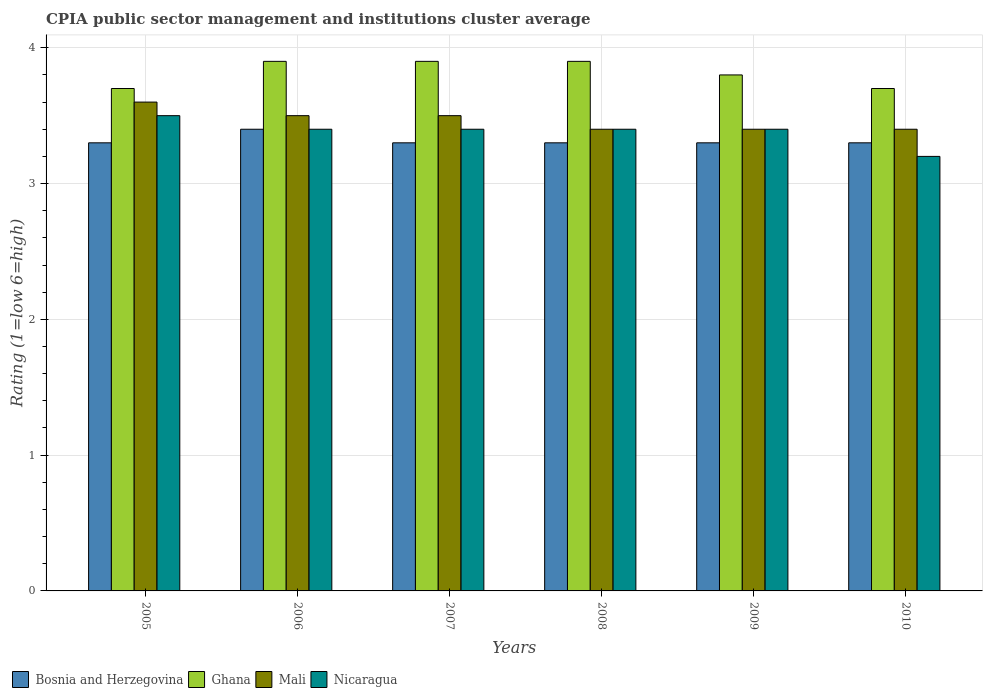Are the number of bars on each tick of the X-axis equal?
Your response must be concise. Yes. How many bars are there on the 2nd tick from the right?
Your answer should be very brief. 4. In how many cases, is the number of bars for a given year not equal to the number of legend labels?
Keep it short and to the point. 0. Across all years, what is the maximum CPIA rating in Ghana?
Give a very brief answer. 3.9. What is the total CPIA rating in Mali in the graph?
Your answer should be very brief. 20.8. What is the difference between the CPIA rating in Mali in 2005 and the CPIA rating in Bosnia and Herzegovina in 2006?
Provide a succinct answer. 0.2. What is the average CPIA rating in Mali per year?
Ensure brevity in your answer.  3.47. In the year 2008, what is the difference between the CPIA rating in Mali and CPIA rating in Nicaragua?
Your response must be concise. 0. In how many years, is the CPIA rating in Ghana greater than 2.4?
Your answer should be compact. 6. What is the ratio of the CPIA rating in Ghana in 2005 to that in 2008?
Provide a succinct answer. 0.95. Is the CPIA rating in Bosnia and Herzegovina in 2005 less than that in 2007?
Ensure brevity in your answer.  No. Is the difference between the CPIA rating in Mali in 2005 and 2006 greater than the difference between the CPIA rating in Nicaragua in 2005 and 2006?
Ensure brevity in your answer.  No. What is the difference between the highest and the second highest CPIA rating in Ghana?
Your answer should be compact. 0. What is the difference between the highest and the lowest CPIA rating in Bosnia and Herzegovina?
Keep it short and to the point. 0.1. In how many years, is the CPIA rating in Ghana greater than the average CPIA rating in Ghana taken over all years?
Provide a short and direct response. 3. Is the sum of the CPIA rating in Nicaragua in 2005 and 2010 greater than the maximum CPIA rating in Mali across all years?
Your answer should be very brief. Yes. What does the 1st bar from the left in 2010 represents?
Ensure brevity in your answer.  Bosnia and Herzegovina. What does the 4th bar from the right in 2009 represents?
Give a very brief answer. Bosnia and Herzegovina. Is it the case that in every year, the sum of the CPIA rating in Bosnia and Herzegovina and CPIA rating in Ghana is greater than the CPIA rating in Mali?
Ensure brevity in your answer.  Yes. How many bars are there?
Your answer should be very brief. 24. Are all the bars in the graph horizontal?
Make the answer very short. No. Are the values on the major ticks of Y-axis written in scientific E-notation?
Provide a short and direct response. No. Where does the legend appear in the graph?
Ensure brevity in your answer.  Bottom left. How many legend labels are there?
Provide a short and direct response. 4. How are the legend labels stacked?
Make the answer very short. Horizontal. What is the title of the graph?
Make the answer very short. CPIA public sector management and institutions cluster average. What is the label or title of the Y-axis?
Offer a very short reply. Rating (1=low 6=high). What is the Rating (1=low 6=high) of Ghana in 2005?
Keep it short and to the point. 3.7. What is the Rating (1=low 6=high) in Mali in 2005?
Offer a terse response. 3.6. What is the Rating (1=low 6=high) in Bosnia and Herzegovina in 2006?
Offer a very short reply. 3.4. What is the Rating (1=low 6=high) in Ghana in 2006?
Offer a terse response. 3.9. What is the Rating (1=low 6=high) of Nicaragua in 2006?
Make the answer very short. 3.4. What is the Rating (1=low 6=high) of Ghana in 2007?
Your answer should be compact. 3.9. What is the Rating (1=low 6=high) of Nicaragua in 2007?
Provide a short and direct response. 3.4. What is the Rating (1=low 6=high) in Bosnia and Herzegovina in 2008?
Provide a short and direct response. 3.3. What is the Rating (1=low 6=high) of Mali in 2008?
Your response must be concise. 3.4. What is the Rating (1=low 6=high) of Nicaragua in 2008?
Your response must be concise. 3.4. What is the Rating (1=low 6=high) of Ghana in 2009?
Your answer should be compact. 3.8. What is the Rating (1=low 6=high) in Nicaragua in 2009?
Provide a short and direct response. 3.4. What is the Rating (1=low 6=high) of Ghana in 2010?
Ensure brevity in your answer.  3.7. What is the Rating (1=low 6=high) of Nicaragua in 2010?
Offer a very short reply. 3.2. Across all years, what is the maximum Rating (1=low 6=high) of Bosnia and Herzegovina?
Provide a short and direct response. 3.4. Across all years, what is the maximum Rating (1=low 6=high) of Ghana?
Your response must be concise. 3.9. Across all years, what is the minimum Rating (1=low 6=high) in Ghana?
Your answer should be very brief. 3.7. Across all years, what is the minimum Rating (1=low 6=high) of Mali?
Provide a short and direct response. 3.4. What is the total Rating (1=low 6=high) of Bosnia and Herzegovina in the graph?
Give a very brief answer. 19.9. What is the total Rating (1=low 6=high) of Ghana in the graph?
Your answer should be compact. 22.9. What is the total Rating (1=low 6=high) of Mali in the graph?
Provide a short and direct response. 20.8. What is the total Rating (1=low 6=high) of Nicaragua in the graph?
Make the answer very short. 20.3. What is the difference between the Rating (1=low 6=high) of Bosnia and Herzegovina in 2005 and that in 2006?
Give a very brief answer. -0.1. What is the difference between the Rating (1=low 6=high) of Ghana in 2005 and that in 2006?
Make the answer very short. -0.2. What is the difference between the Rating (1=low 6=high) in Mali in 2005 and that in 2006?
Provide a short and direct response. 0.1. What is the difference between the Rating (1=low 6=high) in Nicaragua in 2005 and that in 2006?
Your answer should be compact. 0.1. What is the difference between the Rating (1=low 6=high) of Ghana in 2005 and that in 2007?
Give a very brief answer. -0.2. What is the difference between the Rating (1=low 6=high) in Bosnia and Herzegovina in 2005 and that in 2009?
Make the answer very short. 0. What is the difference between the Rating (1=low 6=high) of Ghana in 2005 and that in 2009?
Your answer should be very brief. -0.1. What is the difference between the Rating (1=low 6=high) of Bosnia and Herzegovina in 2005 and that in 2010?
Make the answer very short. 0. What is the difference between the Rating (1=low 6=high) of Bosnia and Herzegovina in 2006 and that in 2007?
Make the answer very short. 0.1. What is the difference between the Rating (1=low 6=high) of Ghana in 2006 and that in 2007?
Provide a short and direct response. 0. What is the difference between the Rating (1=low 6=high) in Mali in 2006 and that in 2007?
Your response must be concise. 0. What is the difference between the Rating (1=low 6=high) of Ghana in 2006 and that in 2008?
Make the answer very short. 0. What is the difference between the Rating (1=low 6=high) in Mali in 2006 and that in 2008?
Your answer should be very brief. 0.1. What is the difference between the Rating (1=low 6=high) in Nicaragua in 2006 and that in 2008?
Your response must be concise. 0. What is the difference between the Rating (1=low 6=high) in Ghana in 2006 and that in 2009?
Provide a short and direct response. 0.1. What is the difference between the Rating (1=low 6=high) in Bosnia and Herzegovina in 2007 and that in 2008?
Offer a terse response. 0. What is the difference between the Rating (1=low 6=high) of Mali in 2007 and that in 2008?
Offer a terse response. 0.1. What is the difference between the Rating (1=low 6=high) of Bosnia and Herzegovina in 2007 and that in 2009?
Provide a succinct answer. 0. What is the difference between the Rating (1=low 6=high) of Nicaragua in 2007 and that in 2009?
Offer a very short reply. 0. What is the difference between the Rating (1=low 6=high) in Bosnia and Herzegovina in 2007 and that in 2010?
Your answer should be compact. 0. What is the difference between the Rating (1=low 6=high) of Bosnia and Herzegovina in 2008 and that in 2009?
Your response must be concise. 0. What is the difference between the Rating (1=low 6=high) of Ghana in 2008 and that in 2009?
Keep it short and to the point. 0.1. What is the difference between the Rating (1=low 6=high) in Nicaragua in 2008 and that in 2009?
Keep it short and to the point. 0. What is the difference between the Rating (1=low 6=high) in Bosnia and Herzegovina in 2008 and that in 2010?
Give a very brief answer. 0. What is the difference between the Rating (1=low 6=high) of Ghana in 2008 and that in 2010?
Provide a succinct answer. 0.2. What is the difference between the Rating (1=low 6=high) of Mali in 2008 and that in 2010?
Ensure brevity in your answer.  0. What is the difference between the Rating (1=low 6=high) in Nicaragua in 2008 and that in 2010?
Provide a succinct answer. 0.2. What is the difference between the Rating (1=low 6=high) of Bosnia and Herzegovina in 2009 and that in 2010?
Make the answer very short. 0. What is the difference between the Rating (1=low 6=high) of Mali in 2009 and that in 2010?
Your response must be concise. 0. What is the difference between the Rating (1=low 6=high) in Nicaragua in 2009 and that in 2010?
Provide a succinct answer. 0.2. What is the difference between the Rating (1=low 6=high) of Bosnia and Herzegovina in 2005 and the Rating (1=low 6=high) of Ghana in 2006?
Offer a terse response. -0.6. What is the difference between the Rating (1=low 6=high) of Bosnia and Herzegovina in 2005 and the Rating (1=low 6=high) of Nicaragua in 2006?
Your answer should be compact. -0.1. What is the difference between the Rating (1=low 6=high) of Ghana in 2005 and the Rating (1=low 6=high) of Mali in 2006?
Provide a short and direct response. 0.2. What is the difference between the Rating (1=low 6=high) of Ghana in 2005 and the Rating (1=low 6=high) of Nicaragua in 2006?
Ensure brevity in your answer.  0.3. What is the difference between the Rating (1=low 6=high) of Bosnia and Herzegovina in 2005 and the Rating (1=low 6=high) of Ghana in 2007?
Make the answer very short. -0.6. What is the difference between the Rating (1=low 6=high) of Bosnia and Herzegovina in 2005 and the Rating (1=low 6=high) of Mali in 2007?
Provide a succinct answer. -0.2. What is the difference between the Rating (1=low 6=high) of Ghana in 2005 and the Rating (1=low 6=high) of Mali in 2007?
Your answer should be compact. 0.2. What is the difference between the Rating (1=low 6=high) of Mali in 2005 and the Rating (1=low 6=high) of Nicaragua in 2007?
Offer a very short reply. 0.2. What is the difference between the Rating (1=low 6=high) of Bosnia and Herzegovina in 2005 and the Rating (1=low 6=high) of Ghana in 2008?
Your response must be concise. -0.6. What is the difference between the Rating (1=low 6=high) in Bosnia and Herzegovina in 2005 and the Rating (1=low 6=high) in Nicaragua in 2008?
Offer a very short reply. -0.1. What is the difference between the Rating (1=low 6=high) of Mali in 2005 and the Rating (1=low 6=high) of Nicaragua in 2008?
Keep it short and to the point. 0.2. What is the difference between the Rating (1=low 6=high) in Bosnia and Herzegovina in 2005 and the Rating (1=low 6=high) in Ghana in 2009?
Ensure brevity in your answer.  -0.5. What is the difference between the Rating (1=low 6=high) of Ghana in 2005 and the Rating (1=low 6=high) of Nicaragua in 2009?
Offer a terse response. 0.3. What is the difference between the Rating (1=low 6=high) of Mali in 2005 and the Rating (1=low 6=high) of Nicaragua in 2009?
Provide a short and direct response. 0.2. What is the difference between the Rating (1=low 6=high) of Bosnia and Herzegovina in 2005 and the Rating (1=low 6=high) of Ghana in 2010?
Provide a succinct answer. -0.4. What is the difference between the Rating (1=low 6=high) in Ghana in 2005 and the Rating (1=low 6=high) in Mali in 2010?
Your answer should be very brief. 0.3. What is the difference between the Rating (1=low 6=high) of Bosnia and Herzegovina in 2006 and the Rating (1=low 6=high) of Nicaragua in 2007?
Offer a terse response. 0. What is the difference between the Rating (1=low 6=high) in Bosnia and Herzegovina in 2006 and the Rating (1=low 6=high) in Ghana in 2008?
Ensure brevity in your answer.  -0.5. What is the difference between the Rating (1=low 6=high) in Bosnia and Herzegovina in 2006 and the Rating (1=low 6=high) in Nicaragua in 2008?
Provide a succinct answer. 0. What is the difference between the Rating (1=low 6=high) in Ghana in 2006 and the Rating (1=low 6=high) in Mali in 2008?
Keep it short and to the point. 0.5. What is the difference between the Rating (1=low 6=high) in Ghana in 2006 and the Rating (1=low 6=high) in Nicaragua in 2008?
Provide a short and direct response. 0.5. What is the difference between the Rating (1=low 6=high) of Mali in 2006 and the Rating (1=low 6=high) of Nicaragua in 2008?
Your answer should be compact. 0.1. What is the difference between the Rating (1=low 6=high) in Bosnia and Herzegovina in 2006 and the Rating (1=low 6=high) in Ghana in 2009?
Keep it short and to the point. -0.4. What is the difference between the Rating (1=low 6=high) in Ghana in 2006 and the Rating (1=low 6=high) in Nicaragua in 2009?
Offer a terse response. 0.5. What is the difference between the Rating (1=low 6=high) of Mali in 2006 and the Rating (1=low 6=high) of Nicaragua in 2009?
Provide a succinct answer. 0.1. What is the difference between the Rating (1=low 6=high) of Bosnia and Herzegovina in 2006 and the Rating (1=low 6=high) of Ghana in 2010?
Offer a very short reply. -0.3. What is the difference between the Rating (1=low 6=high) in Ghana in 2006 and the Rating (1=low 6=high) in Nicaragua in 2010?
Make the answer very short. 0.7. What is the difference between the Rating (1=low 6=high) in Bosnia and Herzegovina in 2007 and the Rating (1=low 6=high) in Ghana in 2008?
Provide a succinct answer. -0.6. What is the difference between the Rating (1=low 6=high) in Bosnia and Herzegovina in 2007 and the Rating (1=low 6=high) in Mali in 2008?
Ensure brevity in your answer.  -0.1. What is the difference between the Rating (1=low 6=high) of Bosnia and Herzegovina in 2007 and the Rating (1=low 6=high) of Nicaragua in 2008?
Provide a succinct answer. -0.1. What is the difference between the Rating (1=low 6=high) in Bosnia and Herzegovina in 2007 and the Rating (1=low 6=high) in Mali in 2009?
Make the answer very short. -0.1. What is the difference between the Rating (1=low 6=high) in Bosnia and Herzegovina in 2007 and the Rating (1=low 6=high) in Nicaragua in 2009?
Provide a short and direct response. -0.1. What is the difference between the Rating (1=low 6=high) of Bosnia and Herzegovina in 2007 and the Rating (1=low 6=high) of Ghana in 2010?
Your answer should be very brief. -0.4. What is the difference between the Rating (1=low 6=high) of Bosnia and Herzegovina in 2007 and the Rating (1=low 6=high) of Mali in 2010?
Offer a very short reply. -0.1. What is the difference between the Rating (1=low 6=high) of Bosnia and Herzegovina in 2007 and the Rating (1=low 6=high) of Nicaragua in 2010?
Offer a very short reply. 0.1. What is the difference between the Rating (1=low 6=high) in Bosnia and Herzegovina in 2008 and the Rating (1=low 6=high) in Ghana in 2009?
Offer a terse response. -0.5. What is the difference between the Rating (1=low 6=high) of Bosnia and Herzegovina in 2008 and the Rating (1=low 6=high) of Mali in 2009?
Ensure brevity in your answer.  -0.1. What is the difference between the Rating (1=low 6=high) in Bosnia and Herzegovina in 2008 and the Rating (1=low 6=high) in Nicaragua in 2009?
Your answer should be compact. -0.1. What is the difference between the Rating (1=low 6=high) in Ghana in 2008 and the Rating (1=low 6=high) in Mali in 2009?
Offer a terse response. 0.5. What is the difference between the Rating (1=low 6=high) of Mali in 2008 and the Rating (1=low 6=high) of Nicaragua in 2009?
Offer a terse response. 0. What is the difference between the Rating (1=low 6=high) in Bosnia and Herzegovina in 2008 and the Rating (1=low 6=high) in Mali in 2010?
Your answer should be very brief. -0.1. What is the difference between the Rating (1=low 6=high) in Ghana in 2008 and the Rating (1=low 6=high) in Mali in 2010?
Offer a terse response. 0.5. What is the difference between the Rating (1=low 6=high) of Ghana in 2008 and the Rating (1=low 6=high) of Nicaragua in 2010?
Provide a succinct answer. 0.7. What is the difference between the Rating (1=low 6=high) of Mali in 2008 and the Rating (1=low 6=high) of Nicaragua in 2010?
Your answer should be compact. 0.2. What is the difference between the Rating (1=low 6=high) of Bosnia and Herzegovina in 2009 and the Rating (1=low 6=high) of Ghana in 2010?
Keep it short and to the point. -0.4. What is the difference between the Rating (1=low 6=high) of Bosnia and Herzegovina in 2009 and the Rating (1=low 6=high) of Nicaragua in 2010?
Offer a very short reply. 0.1. What is the difference between the Rating (1=low 6=high) in Mali in 2009 and the Rating (1=low 6=high) in Nicaragua in 2010?
Offer a terse response. 0.2. What is the average Rating (1=low 6=high) in Bosnia and Herzegovina per year?
Provide a short and direct response. 3.32. What is the average Rating (1=low 6=high) of Ghana per year?
Offer a very short reply. 3.82. What is the average Rating (1=low 6=high) of Mali per year?
Ensure brevity in your answer.  3.47. What is the average Rating (1=low 6=high) in Nicaragua per year?
Provide a short and direct response. 3.38. In the year 2005, what is the difference between the Rating (1=low 6=high) in Bosnia and Herzegovina and Rating (1=low 6=high) in Ghana?
Give a very brief answer. -0.4. In the year 2005, what is the difference between the Rating (1=low 6=high) in Bosnia and Herzegovina and Rating (1=low 6=high) in Mali?
Offer a terse response. -0.3. In the year 2005, what is the difference between the Rating (1=low 6=high) of Bosnia and Herzegovina and Rating (1=low 6=high) of Nicaragua?
Your answer should be very brief. -0.2. In the year 2005, what is the difference between the Rating (1=low 6=high) in Ghana and Rating (1=low 6=high) in Mali?
Provide a succinct answer. 0.1. In the year 2005, what is the difference between the Rating (1=low 6=high) in Mali and Rating (1=low 6=high) in Nicaragua?
Your answer should be compact. 0.1. In the year 2006, what is the difference between the Rating (1=low 6=high) of Bosnia and Herzegovina and Rating (1=low 6=high) of Mali?
Give a very brief answer. -0.1. In the year 2006, what is the difference between the Rating (1=low 6=high) in Bosnia and Herzegovina and Rating (1=low 6=high) in Nicaragua?
Your response must be concise. 0. In the year 2006, what is the difference between the Rating (1=low 6=high) in Ghana and Rating (1=low 6=high) in Nicaragua?
Your response must be concise. 0.5. In the year 2007, what is the difference between the Rating (1=low 6=high) of Bosnia and Herzegovina and Rating (1=low 6=high) of Mali?
Provide a short and direct response. -0.2. In the year 2007, what is the difference between the Rating (1=low 6=high) of Bosnia and Herzegovina and Rating (1=low 6=high) of Nicaragua?
Offer a very short reply. -0.1. In the year 2008, what is the difference between the Rating (1=low 6=high) of Ghana and Rating (1=low 6=high) of Nicaragua?
Make the answer very short. 0.5. In the year 2009, what is the difference between the Rating (1=low 6=high) of Bosnia and Herzegovina and Rating (1=low 6=high) of Ghana?
Keep it short and to the point. -0.5. In the year 2009, what is the difference between the Rating (1=low 6=high) in Bosnia and Herzegovina and Rating (1=low 6=high) in Mali?
Ensure brevity in your answer.  -0.1. In the year 2009, what is the difference between the Rating (1=low 6=high) in Bosnia and Herzegovina and Rating (1=low 6=high) in Nicaragua?
Your response must be concise. -0.1. In the year 2009, what is the difference between the Rating (1=low 6=high) in Ghana and Rating (1=low 6=high) in Mali?
Ensure brevity in your answer.  0.4. In the year 2009, what is the difference between the Rating (1=low 6=high) in Mali and Rating (1=low 6=high) in Nicaragua?
Give a very brief answer. 0. In the year 2010, what is the difference between the Rating (1=low 6=high) of Bosnia and Herzegovina and Rating (1=low 6=high) of Ghana?
Keep it short and to the point. -0.4. In the year 2010, what is the difference between the Rating (1=low 6=high) in Mali and Rating (1=low 6=high) in Nicaragua?
Keep it short and to the point. 0.2. What is the ratio of the Rating (1=low 6=high) of Bosnia and Herzegovina in 2005 to that in 2006?
Ensure brevity in your answer.  0.97. What is the ratio of the Rating (1=low 6=high) in Ghana in 2005 to that in 2006?
Your answer should be very brief. 0.95. What is the ratio of the Rating (1=low 6=high) in Mali in 2005 to that in 2006?
Your answer should be very brief. 1.03. What is the ratio of the Rating (1=low 6=high) of Nicaragua in 2005 to that in 2006?
Offer a very short reply. 1.03. What is the ratio of the Rating (1=low 6=high) of Ghana in 2005 to that in 2007?
Give a very brief answer. 0.95. What is the ratio of the Rating (1=low 6=high) in Mali in 2005 to that in 2007?
Your response must be concise. 1.03. What is the ratio of the Rating (1=low 6=high) of Nicaragua in 2005 to that in 2007?
Offer a terse response. 1.03. What is the ratio of the Rating (1=low 6=high) of Bosnia and Herzegovina in 2005 to that in 2008?
Your response must be concise. 1. What is the ratio of the Rating (1=low 6=high) in Ghana in 2005 to that in 2008?
Provide a short and direct response. 0.95. What is the ratio of the Rating (1=low 6=high) of Mali in 2005 to that in 2008?
Keep it short and to the point. 1.06. What is the ratio of the Rating (1=low 6=high) in Nicaragua in 2005 to that in 2008?
Keep it short and to the point. 1.03. What is the ratio of the Rating (1=low 6=high) in Ghana in 2005 to that in 2009?
Provide a succinct answer. 0.97. What is the ratio of the Rating (1=low 6=high) of Mali in 2005 to that in 2009?
Offer a very short reply. 1.06. What is the ratio of the Rating (1=low 6=high) in Nicaragua in 2005 to that in 2009?
Your response must be concise. 1.03. What is the ratio of the Rating (1=low 6=high) of Bosnia and Herzegovina in 2005 to that in 2010?
Provide a succinct answer. 1. What is the ratio of the Rating (1=low 6=high) of Mali in 2005 to that in 2010?
Make the answer very short. 1.06. What is the ratio of the Rating (1=low 6=high) of Nicaragua in 2005 to that in 2010?
Ensure brevity in your answer.  1.09. What is the ratio of the Rating (1=low 6=high) in Bosnia and Herzegovina in 2006 to that in 2007?
Keep it short and to the point. 1.03. What is the ratio of the Rating (1=low 6=high) of Ghana in 2006 to that in 2007?
Offer a very short reply. 1. What is the ratio of the Rating (1=low 6=high) of Nicaragua in 2006 to that in 2007?
Make the answer very short. 1. What is the ratio of the Rating (1=low 6=high) in Bosnia and Herzegovina in 2006 to that in 2008?
Provide a short and direct response. 1.03. What is the ratio of the Rating (1=low 6=high) of Mali in 2006 to that in 2008?
Provide a short and direct response. 1.03. What is the ratio of the Rating (1=low 6=high) in Bosnia and Herzegovina in 2006 to that in 2009?
Provide a succinct answer. 1.03. What is the ratio of the Rating (1=low 6=high) in Ghana in 2006 to that in 2009?
Provide a succinct answer. 1.03. What is the ratio of the Rating (1=low 6=high) of Mali in 2006 to that in 2009?
Your answer should be compact. 1.03. What is the ratio of the Rating (1=low 6=high) in Nicaragua in 2006 to that in 2009?
Ensure brevity in your answer.  1. What is the ratio of the Rating (1=low 6=high) of Bosnia and Herzegovina in 2006 to that in 2010?
Ensure brevity in your answer.  1.03. What is the ratio of the Rating (1=low 6=high) in Ghana in 2006 to that in 2010?
Your answer should be compact. 1.05. What is the ratio of the Rating (1=low 6=high) of Mali in 2006 to that in 2010?
Provide a succinct answer. 1.03. What is the ratio of the Rating (1=low 6=high) of Bosnia and Herzegovina in 2007 to that in 2008?
Your response must be concise. 1. What is the ratio of the Rating (1=low 6=high) of Ghana in 2007 to that in 2008?
Provide a succinct answer. 1. What is the ratio of the Rating (1=low 6=high) of Mali in 2007 to that in 2008?
Provide a short and direct response. 1.03. What is the ratio of the Rating (1=low 6=high) in Nicaragua in 2007 to that in 2008?
Your answer should be very brief. 1. What is the ratio of the Rating (1=low 6=high) in Bosnia and Herzegovina in 2007 to that in 2009?
Your answer should be compact. 1. What is the ratio of the Rating (1=low 6=high) in Ghana in 2007 to that in 2009?
Provide a succinct answer. 1.03. What is the ratio of the Rating (1=low 6=high) in Mali in 2007 to that in 2009?
Provide a short and direct response. 1.03. What is the ratio of the Rating (1=low 6=high) in Bosnia and Herzegovina in 2007 to that in 2010?
Offer a very short reply. 1. What is the ratio of the Rating (1=low 6=high) of Ghana in 2007 to that in 2010?
Give a very brief answer. 1.05. What is the ratio of the Rating (1=low 6=high) in Mali in 2007 to that in 2010?
Provide a short and direct response. 1.03. What is the ratio of the Rating (1=low 6=high) in Bosnia and Herzegovina in 2008 to that in 2009?
Make the answer very short. 1. What is the ratio of the Rating (1=low 6=high) in Ghana in 2008 to that in 2009?
Keep it short and to the point. 1.03. What is the ratio of the Rating (1=low 6=high) in Mali in 2008 to that in 2009?
Offer a terse response. 1. What is the ratio of the Rating (1=low 6=high) of Nicaragua in 2008 to that in 2009?
Offer a terse response. 1. What is the ratio of the Rating (1=low 6=high) in Ghana in 2008 to that in 2010?
Your answer should be compact. 1.05. What is the ratio of the Rating (1=low 6=high) of Nicaragua in 2008 to that in 2010?
Offer a terse response. 1.06. What is the ratio of the Rating (1=low 6=high) of Mali in 2009 to that in 2010?
Your answer should be compact. 1. What is the difference between the highest and the second highest Rating (1=low 6=high) in Bosnia and Herzegovina?
Make the answer very short. 0.1. What is the difference between the highest and the second highest Rating (1=low 6=high) in Mali?
Your answer should be compact. 0.1. What is the difference between the highest and the second highest Rating (1=low 6=high) of Nicaragua?
Make the answer very short. 0.1. What is the difference between the highest and the lowest Rating (1=low 6=high) in Bosnia and Herzegovina?
Offer a very short reply. 0.1. What is the difference between the highest and the lowest Rating (1=low 6=high) in Ghana?
Ensure brevity in your answer.  0.2. What is the difference between the highest and the lowest Rating (1=low 6=high) of Mali?
Keep it short and to the point. 0.2. 